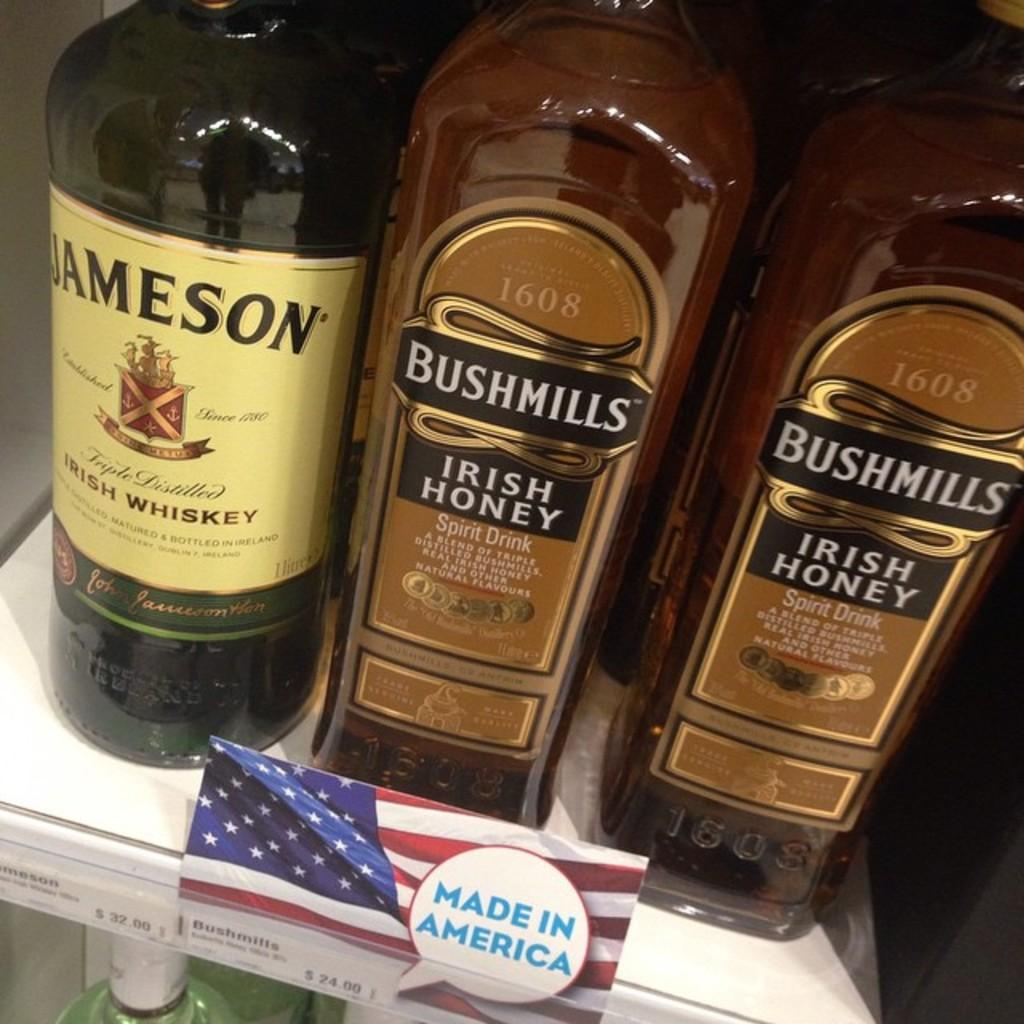How many bottles are visible in the image? There are three bottles in the image. What is inside the bottles? The bottles are filled with a drink. Is there any additional object beside the bottles? Yes, there is a small flag beside the bottles. What type of cord is used to secure the gun in the image? There is no gun present in the image, so there is no cord to secure it. 